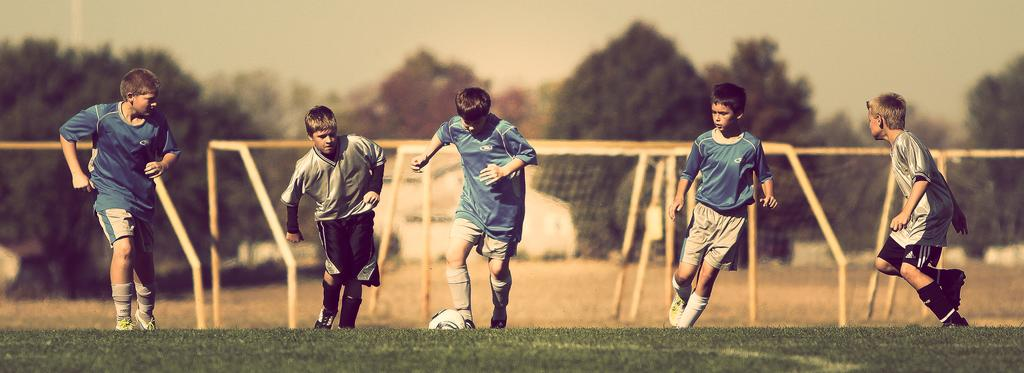What is happening in the image involving the group of kids? The kids are playing with a ball in the image. What type of surface are the kids playing on? There is grass in the image, which suggests they are playing on a grassy area. What sports equipment can be seen in the image? There are football nets in the image. What type of structure is visible in the image? There is a house in the image. What else can be seen in the image besides the kids and the house? There are trees in the image, and the sky is visible in the background. What type of fruit is being used to kick the ball in the image? There is no fruit present in the image, and the kids are not using any fruit to kick the ball. 